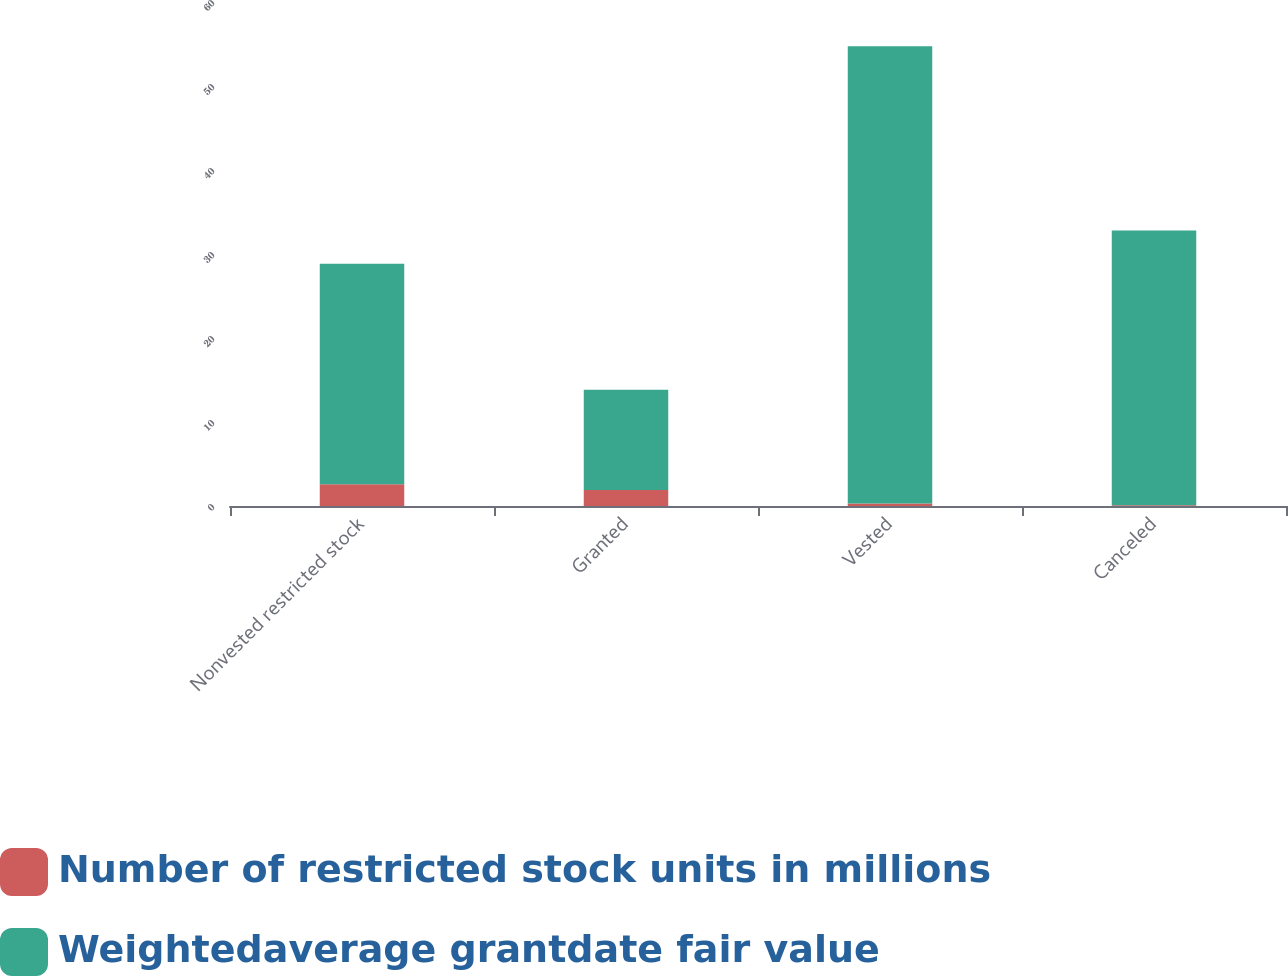Convert chart. <chart><loc_0><loc_0><loc_500><loc_500><stacked_bar_chart><ecel><fcel>Nonvested restricted stock<fcel>Granted<fcel>Vested<fcel>Canceled<nl><fcel>Number of restricted stock units in millions<fcel>2.6<fcel>1.9<fcel>0.3<fcel>0.1<nl><fcel>Weightedaverage grantdate fair value<fcel>26.25<fcel>11.94<fcel>54.42<fcel>32.69<nl></chart> 